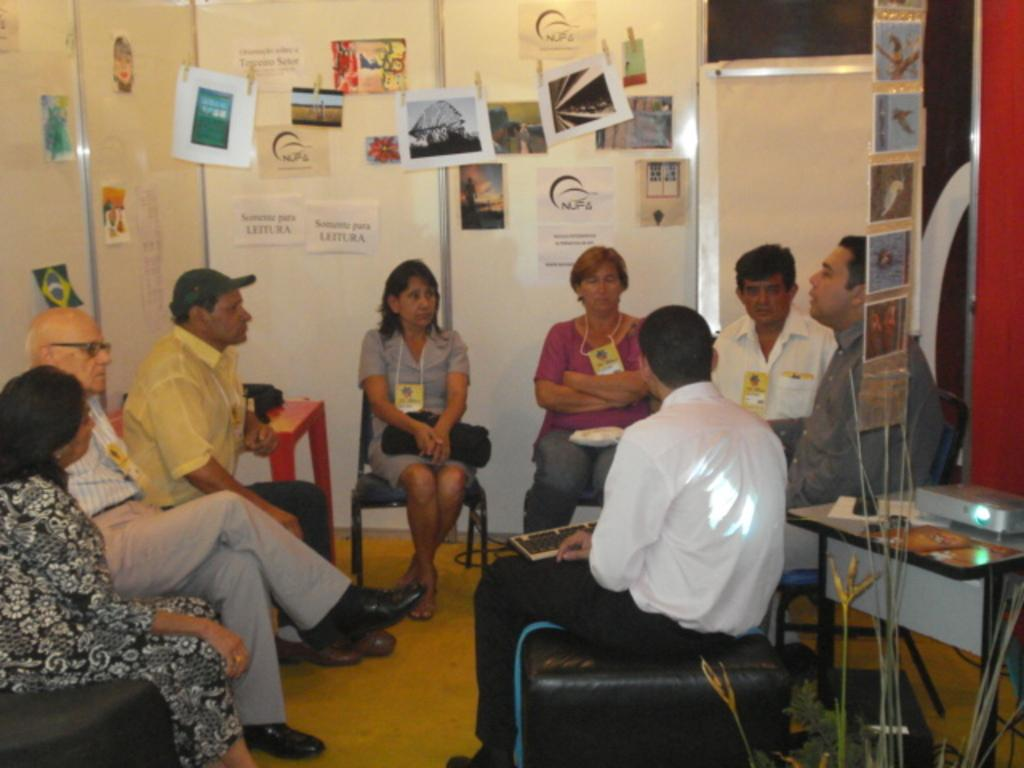What are the people in the image doing? The people in the image are sitting in chairs and discussing with each other. What can be seen on the wall behind the people? There are posters on the wall behind the people. How many boys are present in the image? The provided facts do not mention any boys in the image, so it is impossible to determine their presence or number. 